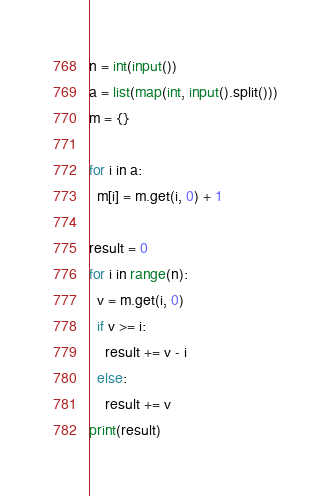<code> <loc_0><loc_0><loc_500><loc_500><_Python_>n = int(input())
a = list(map(int, input().split()))
m = {}

for i in a:
  m[i] = m.get(i, 0) + 1

result = 0
for i in range(n):
  v = m.get(i, 0)
  if v >= i:
    result += v - i
  else:
    result += v
print(result)
</code> 